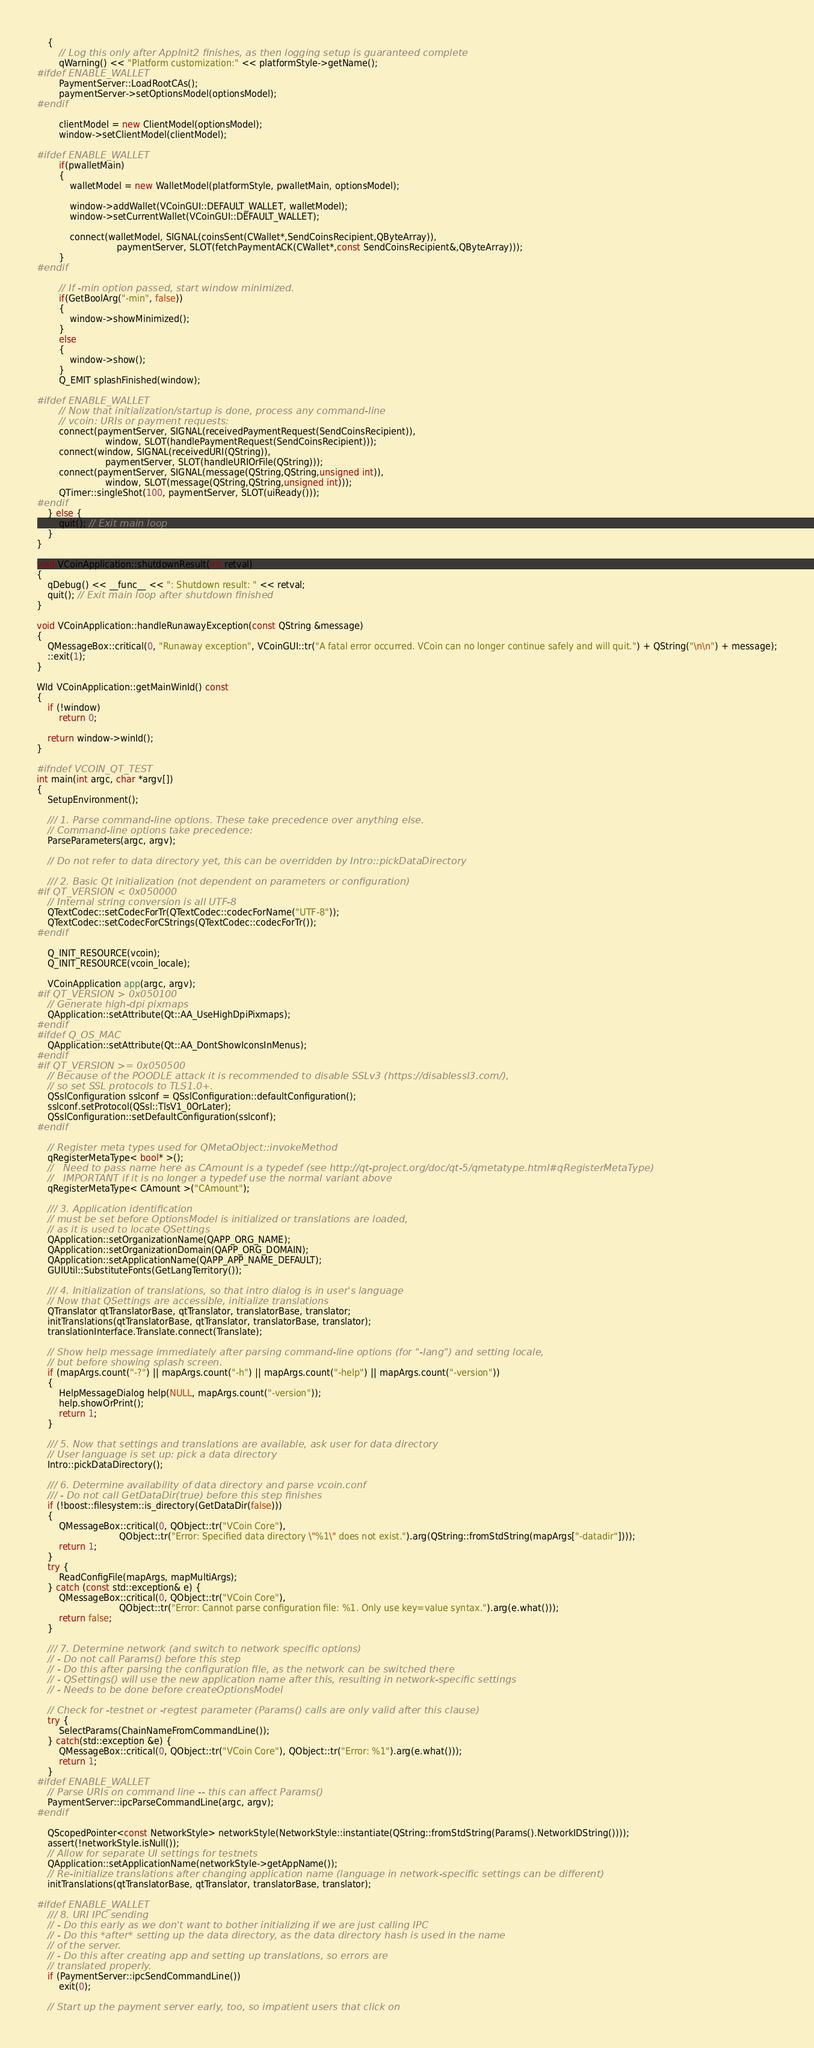<code> <loc_0><loc_0><loc_500><loc_500><_C++_>    {
        // Log this only after AppInit2 finishes, as then logging setup is guaranteed complete
        qWarning() << "Platform customization:" << platformStyle->getName();
#ifdef ENABLE_WALLET
        PaymentServer::LoadRootCAs();
        paymentServer->setOptionsModel(optionsModel);
#endif

        clientModel = new ClientModel(optionsModel);
        window->setClientModel(clientModel);

#ifdef ENABLE_WALLET
        if(pwalletMain)
        {
            walletModel = new WalletModel(platformStyle, pwalletMain, optionsModel);

            window->addWallet(VCoinGUI::DEFAULT_WALLET, walletModel);
            window->setCurrentWallet(VCoinGUI::DEFAULT_WALLET);

            connect(walletModel, SIGNAL(coinsSent(CWallet*,SendCoinsRecipient,QByteArray)),
                             paymentServer, SLOT(fetchPaymentACK(CWallet*,const SendCoinsRecipient&,QByteArray)));
        }
#endif

        // If -min option passed, start window minimized.
        if(GetBoolArg("-min", false))
        {
            window->showMinimized();
        }
        else
        {
            window->show();
        }
        Q_EMIT splashFinished(window);

#ifdef ENABLE_WALLET
        // Now that initialization/startup is done, process any command-line
        // vcoin: URIs or payment requests:
        connect(paymentServer, SIGNAL(receivedPaymentRequest(SendCoinsRecipient)),
                         window, SLOT(handlePaymentRequest(SendCoinsRecipient)));
        connect(window, SIGNAL(receivedURI(QString)),
                         paymentServer, SLOT(handleURIOrFile(QString)));
        connect(paymentServer, SIGNAL(message(QString,QString,unsigned int)),
                         window, SLOT(message(QString,QString,unsigned int)));
        QTimer::singleShot(100, paymentServer, SLOT(uiReady()));
#endif
    } else {
        quit(); // Exit main loop
    }
}

void VCoinApplication::shutdownResult(int retval)
{
    qDebug() << __func__ << ": Shutdown result: " << retval;
    quit(); // Exit main loop after shutdown finished
}

void VCoinApplication::handleRunawayException(const QString &message)
{
    QMessageBox::critical(0, "Runaway exception", VCoinGUI::tr("A fatal error occurred. VCoin can no longer continue safely and will quit.") + QString("\n\n") + message);
    ::exit(1);
}

WId VCoinApplication::getMainWinId() const
{
    if (!window)
        return 0;

    return window->winId();
}

#ifndef VCOIN_QT_TEST
int main(int argc, char *argv[])
{
    SetupEnvironment();

    /// 1. Parse command-line options. These take precedence over anything else.
    // Command-line options take precedence:
    ParseParameters(argc, argv);

    // Do not refer to data directory yet, this can be overridden by Intro::pickDataDirectory

    /// 2. Basic Qt initialization (not dependent on parameters or configuration)
#if QT_VERSION < 0x050000
    // Internal string conversion is all UTF-8
    QTextCodec::setCodecForTr(QTextCodec::codecForName("UTF-8"));
    QTextCodec::setCodecForCStrings(QTextCodec::codecForTr());
#endif

    Q_INIT_RESOURCE(vcoin);
    Q_INIT_RESOURCE(vcoin_locale);

    VCoinApplication app(argc, argv);
#if QT_VERSION > 0x050100
    // Generate high-dpi pixmaps
    QApplication::setAttribute(Qt::AA_UseHighDpiPixmaps);
#endif
#ifdef Q_OS_MAC
    QApplication::setAttribute(Qt::AA_DontShowIconsInMenus);
#endif
#if QT_VERSION >= 0x050500
    // Because of the POODLE attack it is recommended to disable SSLv3 (https://disablessl3.com/),
    // so set SSL protocols to TLS1.0+.
    QSslConfiguration sslconf = QSslConfiguration::defaultConfiguration();
    sslconf.setProtocol(QSsl::TlsV1_0OrLater);
    QSslConfiguration::setDefaultConfiguration(sslconf);
#endif

    // Register meta types used for QMetaObject::invokeMethod
    qRegisterMetaType< bool* >();
    //   Need to pass name here as CAmount is a typedef (see http://qt-project.org/doc/qt-5/qmetatype.html#qRegisterMetaType)
    //   IMPORTANT if it is no longer a typedef use the normal variant above
    qRegisterMetaType< CAmount >("CAmount");

    /// 3. Application identification
    // must be set before OptionsModel is initialized or translations are loaded,
    // as it is used to locate QSettings
    QApplication::setOrganizationName(QAPP_ORG_NAME);
    QApplication::setOrganizationDomain(QAPP_ORG_DOMAIN);
    QApplication::setApplicationName(QAPP_APP_NAME_DEFAULT);
    GUIUtil::SubstituteFonts(GetLangTerritory());

    /// 4. Initialization of translations, so that intro dialog is in user's language
    // Now that QSettings are accessible, initialize translations
    QTranslator qtTranslatorBase, qtTranslator, translatorBase, translator;
    initTranslations(qtTranslatorBase, qtTranslator, translatorBase, translator);
    translationInterface.Translate.connect(Translate);

    // Show help message immediately after parsing command-line options (for "-lang") and setting locale,
    // but before showing splash screen.
    if (mapArgs.count("-?") || mapArgs.count("-h") || mapArgs.count("-help") || mapArgs.count("-version"))
    {
        HelpMessageDialog help(NULL, mapArgs.count("-version"));
        help.showOrPrint();
        return 1;
    }

    /// 5. Now that settings and translations are available, ask user for data directory
    // User language is set up: pick a data directory
    Intro::pickDataDirectory();

    /// 6. Determine availability of data directory and parse vcoin.conf
    /// - Do not call GetDataDir(true) before this step finishes
    if (!boost::filesystem::is_directory(GetDataDir(false)))
    {
        QMessageBox::critical(0, QObject::tr("VCoin Core"),
                              QObject::tr("Error: Specified data directory \"%1\" does not exist.").arg(QString::fromStdString(mapArgs["-datadir"])));
        return 1;
    }
    try {
        ReadConfigFile(mapArgs, mapMultiArgs);
    } catch (const std::exception& e) {
        QMessageBox::critical(0, QObject::tr("VCoin Core"),
                              QObject::tr("Error: Cannot parse configuration file: %1. Only use key=value syntax.").arg(e.what()));
        return false;
    }

    /// 7. Determine network (and switch to network specific options)
    // - Do not call Params() before this step
    // - Do this after parsing the configuration file, as the network can be switched there
    // - QSettings() will use the new application name after this, resulting in network-specific settings
    // - Needs to be done before createOptionsModel

    // Check for -testnet or -regtest parameter (Params() calls are only valid after this clause)
    try {
        SelectParams(ChainNameFromCommandLine());
    } catch(std::exception &e) {
        QMessageBox::critical(0, QObject::tr("VCoin Core"), QObject::tr("Error: %1").arg(e.what()));
        return 1;
    }
#ifdef ENABLE_WALLET
    // Parse URIs on command line -- this can affect Params()
    PaymentServer::ipcParseCommandLine(argc, argv);
#endif

    QScopedPointer<const NetworkStyle> networkStyle(NetworkStyle::instantiate(QString::fromStdString(Params().NetworkIDString())));
    assert(!networkStyle.isNull());
    // Allow for separate UI settings for testnets
    QApplication::setApplicationName(networkStyle->getAppName());
    // Re-initialize translations after changing application name (language in network-specific settings can be different)
    initTranslations(qtTranslatorBase, qtTranslator, translatorBase, translator);

#ifdef ENABLE_WALLET
    /// 8. URI IPC sending
    // - Do this early as we don't want to bother initializing if we are just calling IPC
    // - Do this *after* setting up the data directory, as the data directory hash is used in the name
    // of the server.
    // - Do this after creating app and setting up translations, so errors are
    // translated properly.
    if (PaymentServer::ipcSendCommandLine())
        exit(0);

    // Start up the payment server early, too, so impatient users that click on</code> 